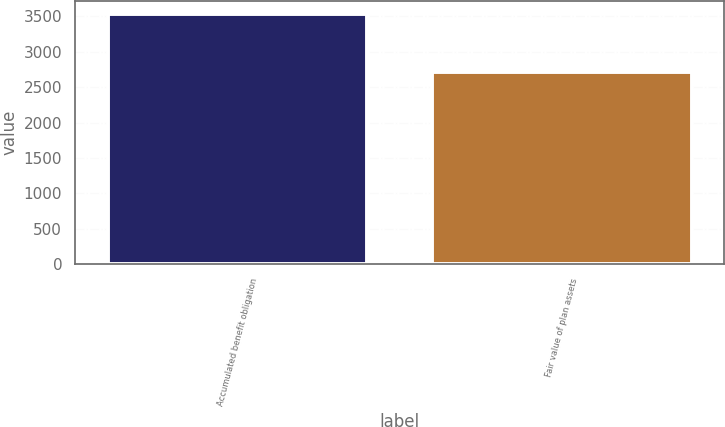Convert chart to OTSL. <chart><loc_0><loc_0><loc_500><loc_500><bar_chart><fcel>Accumulated benefit obligation<fcel>Fair value of plan assets<nl><fcel>3538<fcel>2708<nl></chart> 